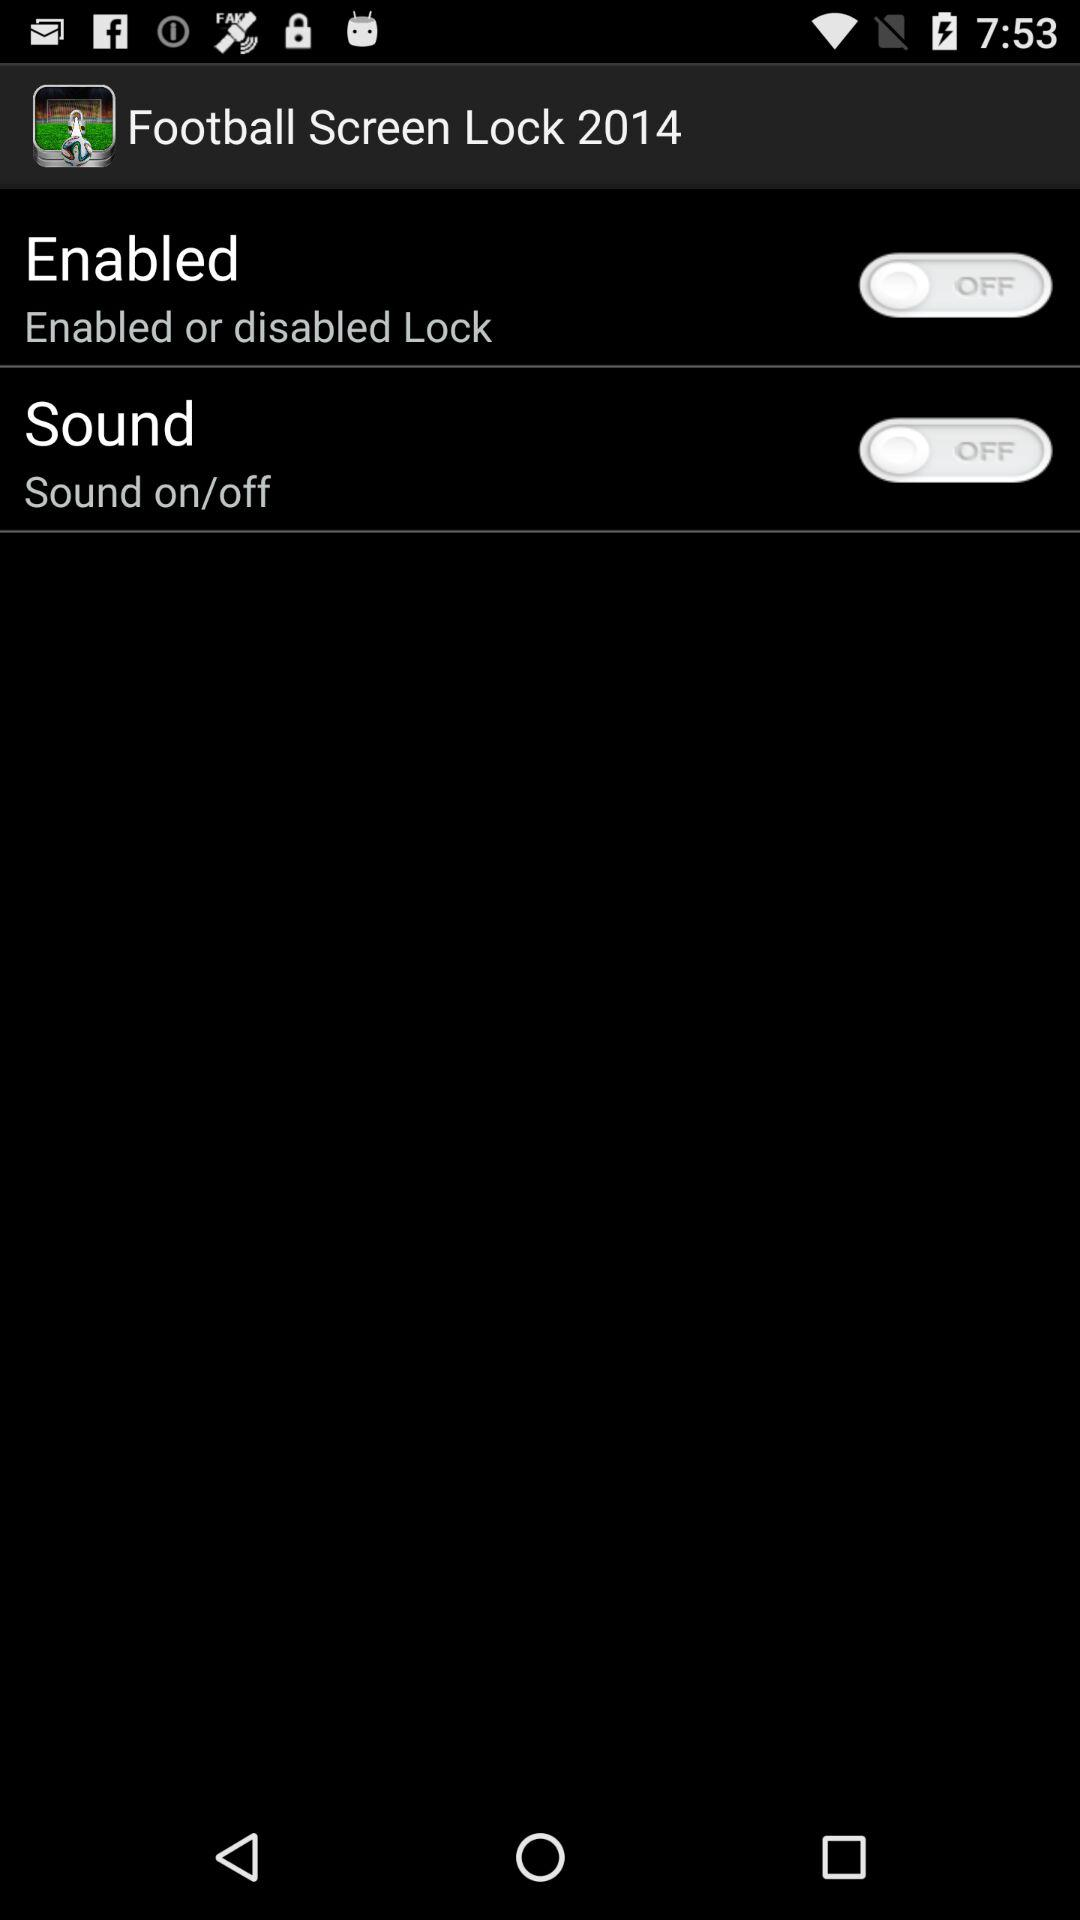What is the status of "Enabled"? The status is "off". 